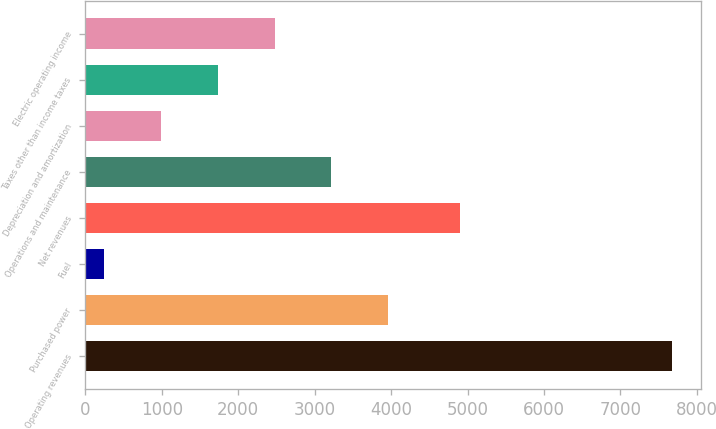<chart> <loc_0><loc_0><loc_500><loc_500><bar_chart><fcel>Operating revenues<fcel>Purchased power<fcel>Fuel<fcel>Net revenues<fcel>Operations and maintenance<fcel>Depreciation and amortization<fcel>Taxes other than income taxes<fcel>Electric operating income<nl><fcel>7674<fcel>3960.5<fcel>247<fcel>4898<fcel>3217.8<fcel>989.7<fcel>1732.4<fcel>2475.1<nl></chart> 